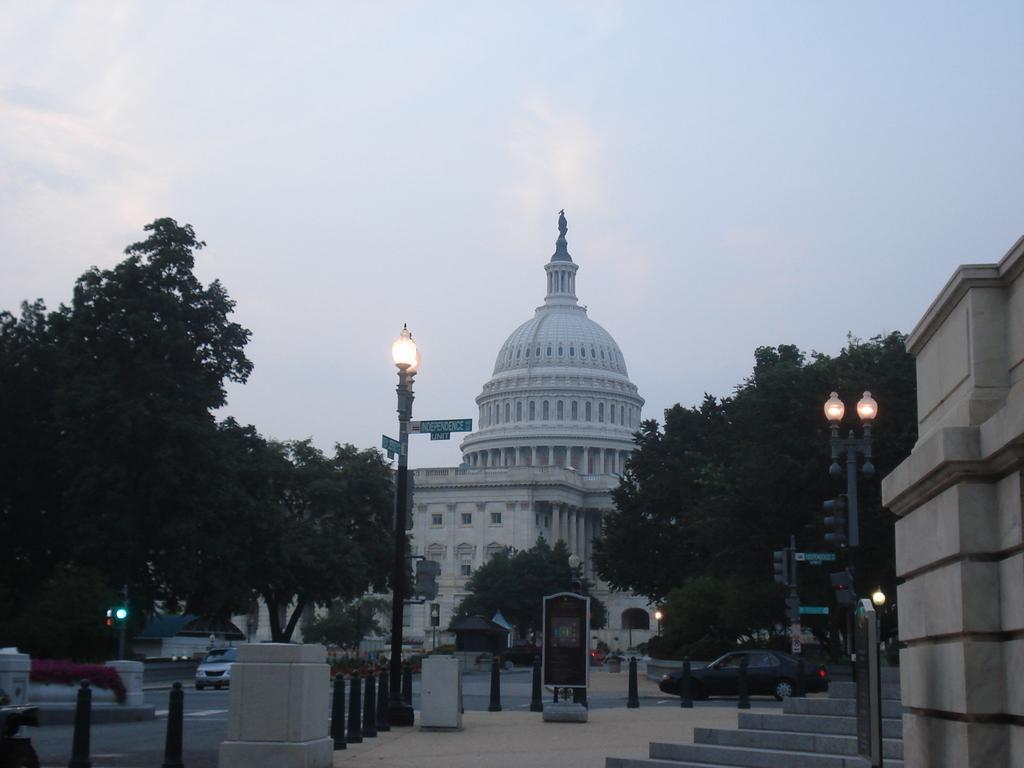Describe this image in one or two sentences. In this image we can see vehicles on the road, light poles, trees, small rods on the footpath, building, boards on the poles and clouds in the sky. 